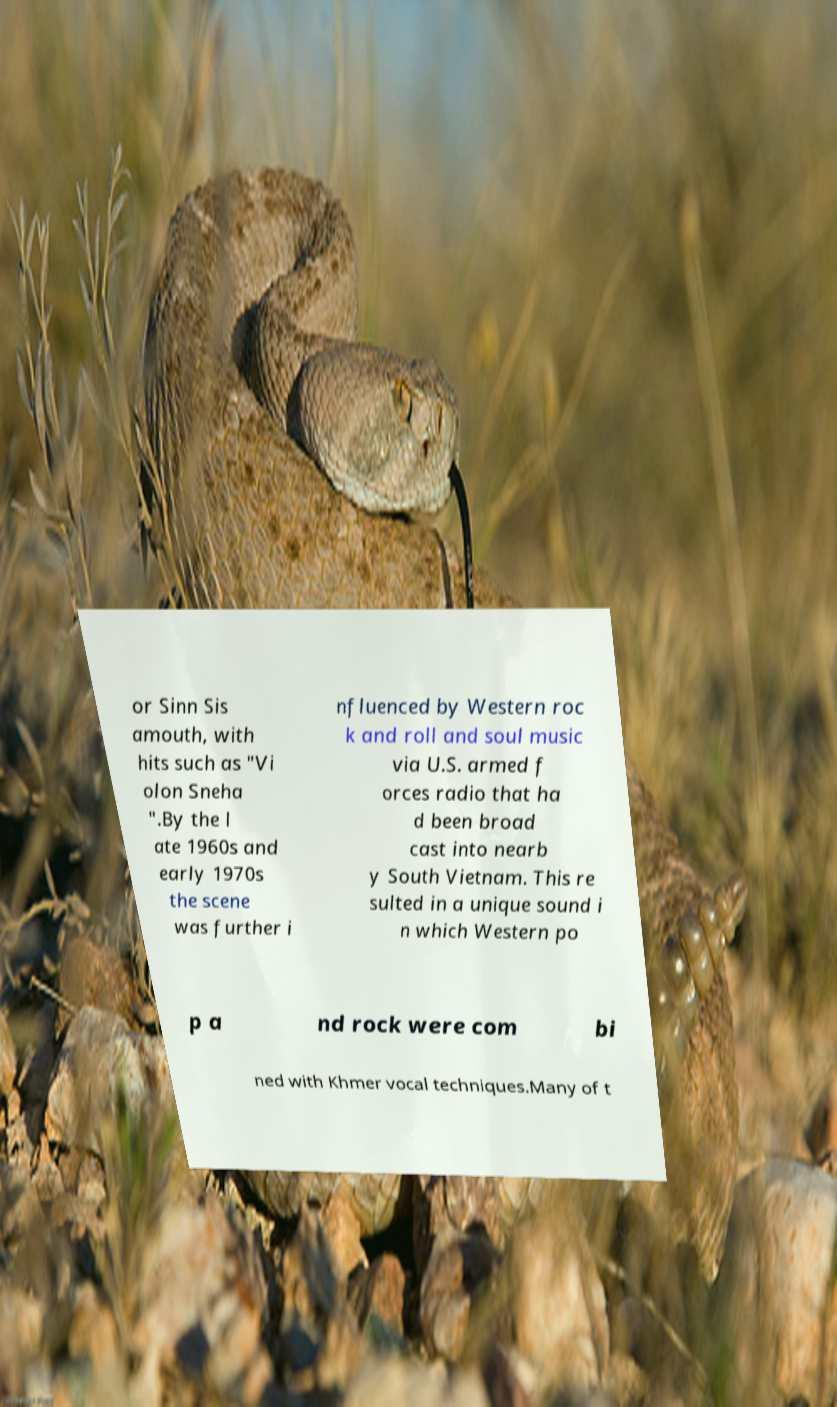Could you assist in decoding the text presented in this image and type it out clearly? or Sinn Sis amouth, with hits such as "Vi olon Sneha ".By the l ate 1960s and early 1970s the scene was further i nfluenced by Western roc k and roll and soul music via U.S. armed f orces radio that ha d been broad cast into nearb y South Vietnam. This re sulted in a unique sound i n which Western po p a nd rock were com bi ned with Khmer vocal techniques.Many of t 